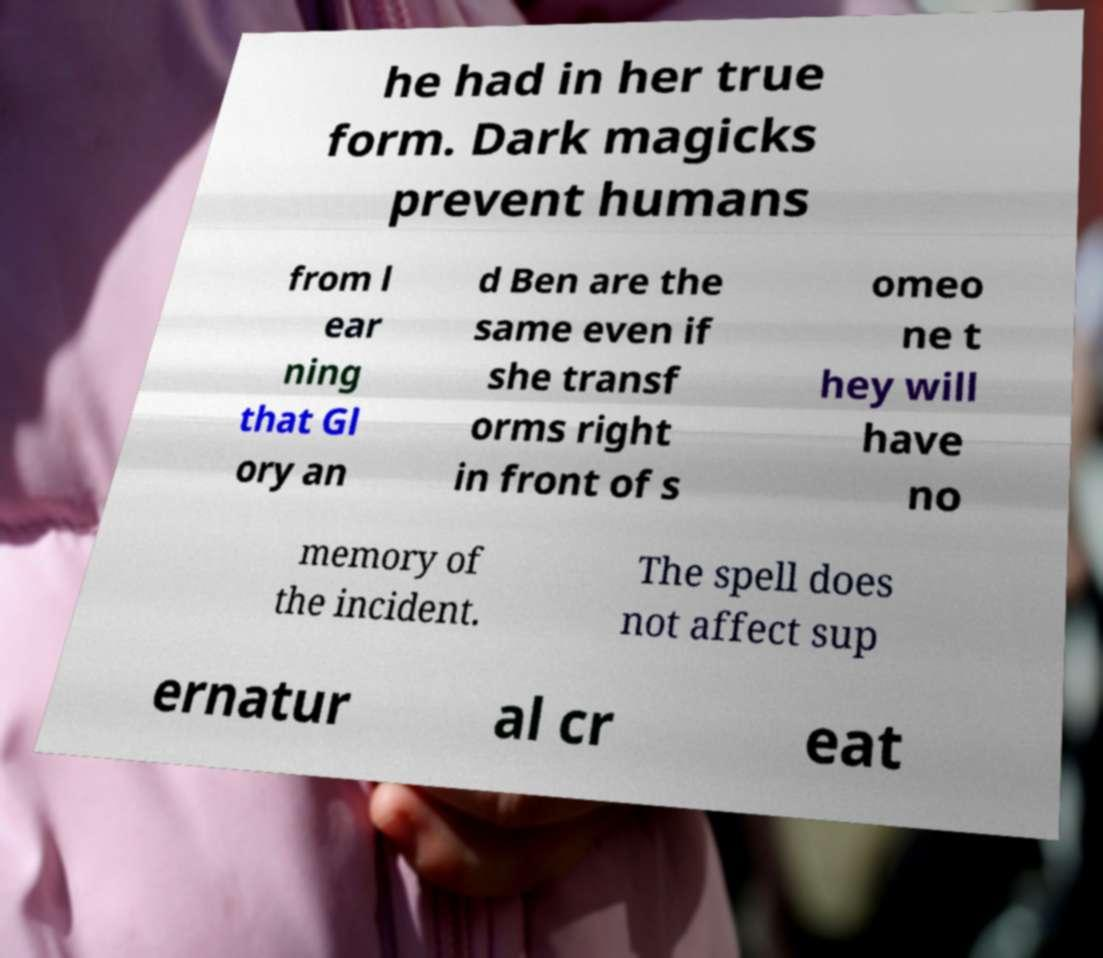For documentation purposes, I need the text within this image transcribed. Could you provide that? he had in her true form. Dark magicks prevent humans from l ear ning that Gl ory an d Ben are the same even if she transf orms right in front of s omeo ne t hey will have no memory of the incident. The spell does not affect sup ernatur al cr eat 